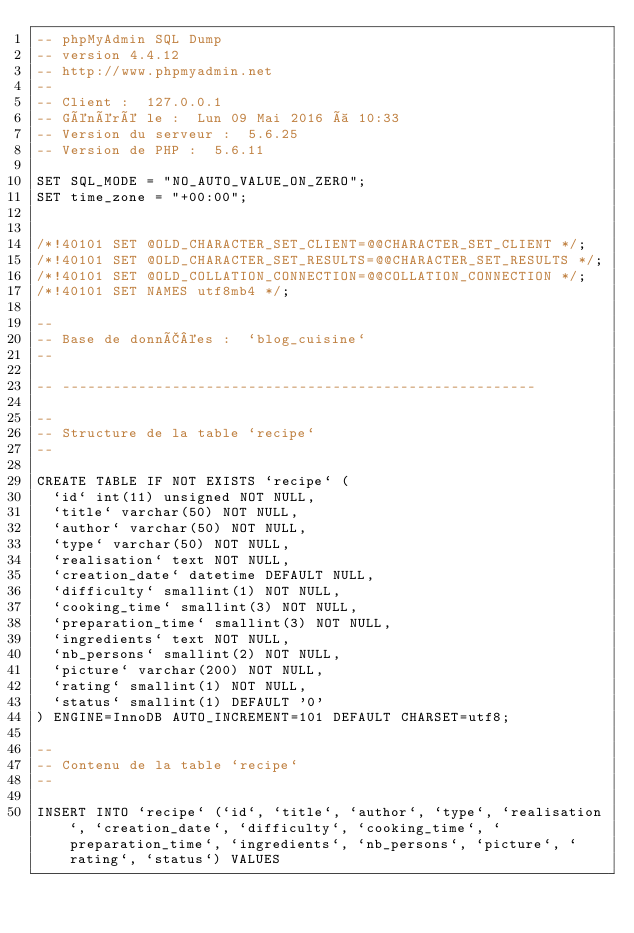Convert code to text. <code><loc_0><loc_0><loc_500><loc_500><_SQL_>-- phpMyAdmin SQL Dump
-- version 4.4.12
-- http://www.phpmyadmin.net
--
-- Client :  127.0.0.1
-- Généré le :  Lun 09 Mai 2016 à 10:33
-- Version du serveur :  5.6.25
-- Version de PHP :  5.6.11

SET SQL_MODE = "NO_AUTO_VALUE_ON_ZERO";
SET time_zone = "+00:00";


/*!40101 SET @OLD_CHARACTER_SET_CLIENT=@@CHARACTER_SET_CLIENT */;
/*!40101 SET @OLD_CHARACTER_SET_RESULTS=@@CHARACTER_SET_RESULTS */;
/*!40101 SET @OLD_COLLATION_CONNECTION=@@COLLATION_CONNECTION */;
/*!40101 SET NAMES utf8mb4 */;

--
-- Base de donnÃ©es :  `blog_cuisine`
--

-- --------------------------------------------------------

--
-- Structure de la table `recipe`
--

CREATE TABLE IF NOT EXISTS `recipe` (
  `id` int(11) unsigned NOT NULL,
  `title` varchar(50) NOT NULL,
  `author` varchar(50) NOT NULL,
  `type` varchar(50) NOT NULL,
  `realisation` text NOT NULL,
  `creation_date` datetime DEFAULT NULL,
  `difficulty` smallint(1) NOT NULL,
  `cooking_time` smallint(3) NOT NULL,
  `preparation_time` smallint(3) NOT NULL,
  `ingredients` text NOT NULL,
  `nb_persons` smallint(2) NOT NULL,
  `picture` varchar(200) NOT NULL,
  `rating` smallint(1) NOT NULL,
  `status` smallint(1) DEFAULT '0'
) ENGINE=InnoDB AUTO_INCREMENT=101 DEFAULT CHARSET=utf8;

--
-- Contenu de la table `recipe`
--

INSERT INTO `recipe` (`id`, `title`, `author`, `type`, `realisation`, `creation_date`, `difficulty`, `cooking_time`, `preparation_time`, `ingredients`, `nb_persons`, `picture`, `rating`, `status`) VALUES</code> 